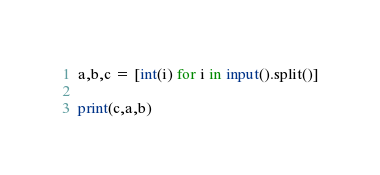Convert code to text. <code><loc_0><loc_0><loc_500><loc_500><_Python_>a,b,c = [int(i) for i in input().split()]

print(c,a,b)

</code> 